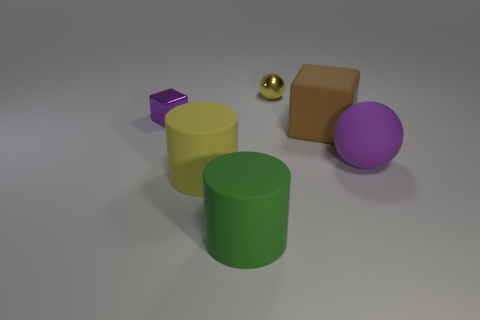Add 2 small cyan cubes. How many objects exist? 8 Subtract all cylinders. How many objects are left? 4 Subtract 0 gray cubes. How many objects are left? 6 Subtract all big cyan matte spheres. Subtract all big cylinders. How many objects are left? 4 Add 2 purple shiny blocks. How many purple shiny blocks are left? 3 Add 5 tiny shiny blocks. How many tiny shiny blocks exist? 6 